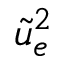<formula> <loc_0><loc_0><loc_500><loc_500>\tilde { u } _ { e } ^ { 2 }</formula> 